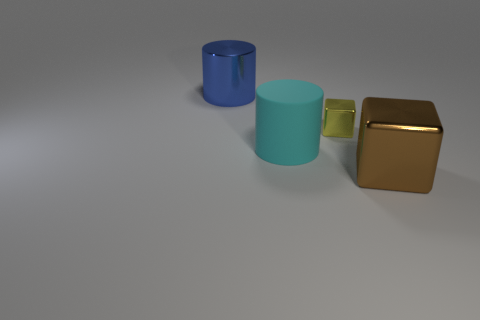What number of blocks have the same size as the brown object? All objects displayed appear to be of different sizes. The brown object is a cube, and it does not share its dimensions with any other object in the image. Therefore, there are no blocks with the same size as the brown object. 